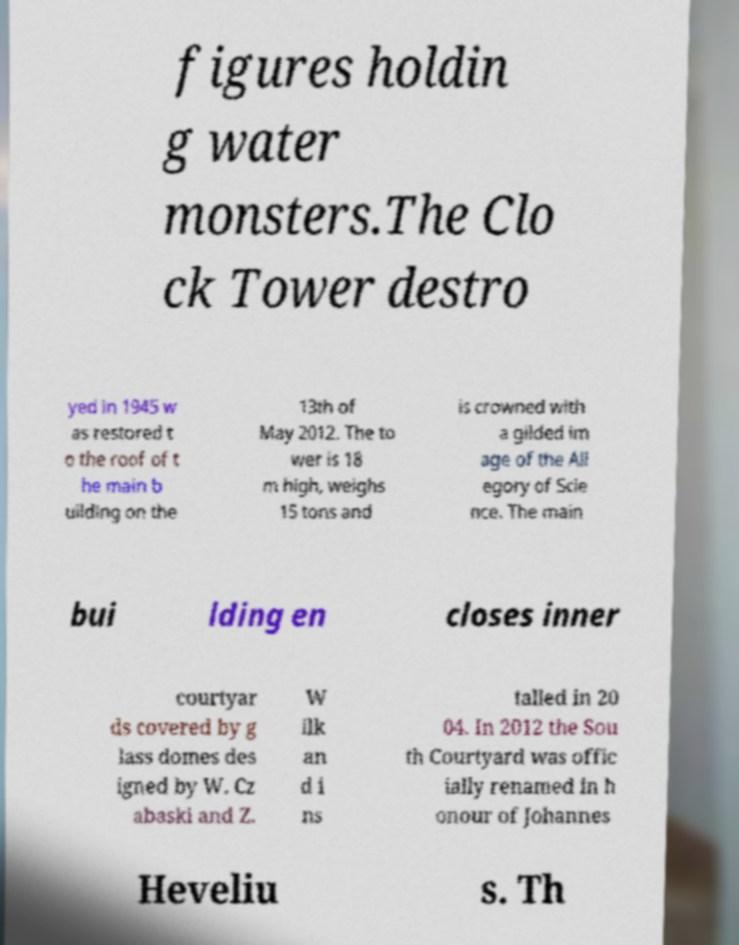There's text embedded in this image that I need extracted. Can you transcribe it verbatim? figures holdin g water monsters.The Clo ck Tower destro yed in 1945 w as restored t o the roof of t he main b uilding on the 13th of May 2012. The to wer is 18 m high, weighs 15 tons and is crowned with a gilded im age of the All egory of Scie nce. The main bui lding en closes inner courtyar ds covered by g lass domes des igned by W. Cz abaski and Z. W ilk an d i ns talled in 20 04. In 2012 the Sou th Courtyard was offic ially renamed in h onour of Johannes Heveliu s. Th 